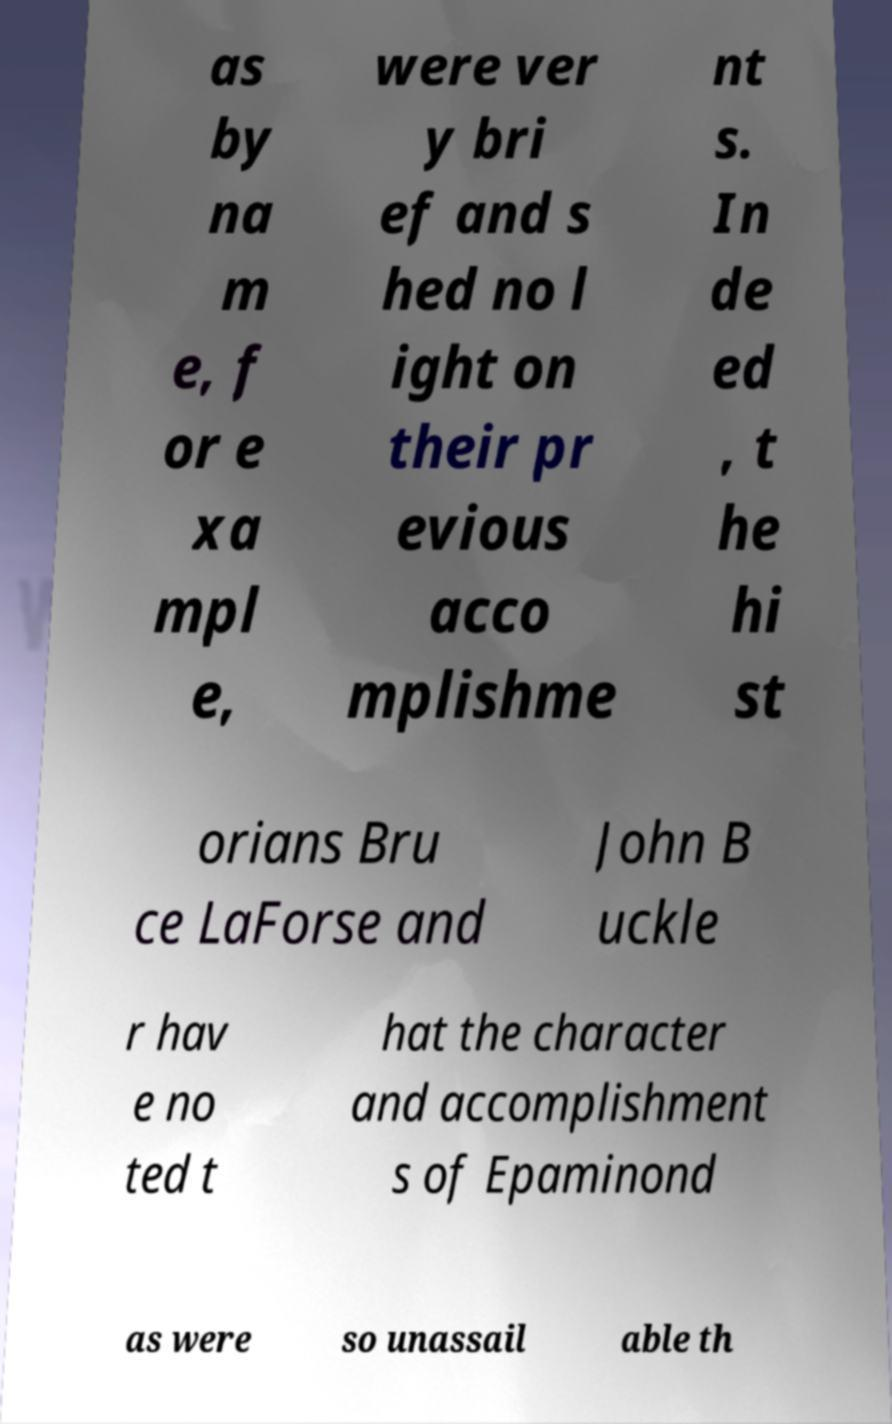Can you accurately transcribe the text from the provided image for me? as by na m e, f or e xa mpl e, were ver y bri ef and s hed no l ight on their pr evious acco mplishme nt s. In de ed , t he hi st orians Bru ce LaForse and John B uckle r hav e no ted t hat the character and accomplishment s of Epaminond as were so unassail able th 